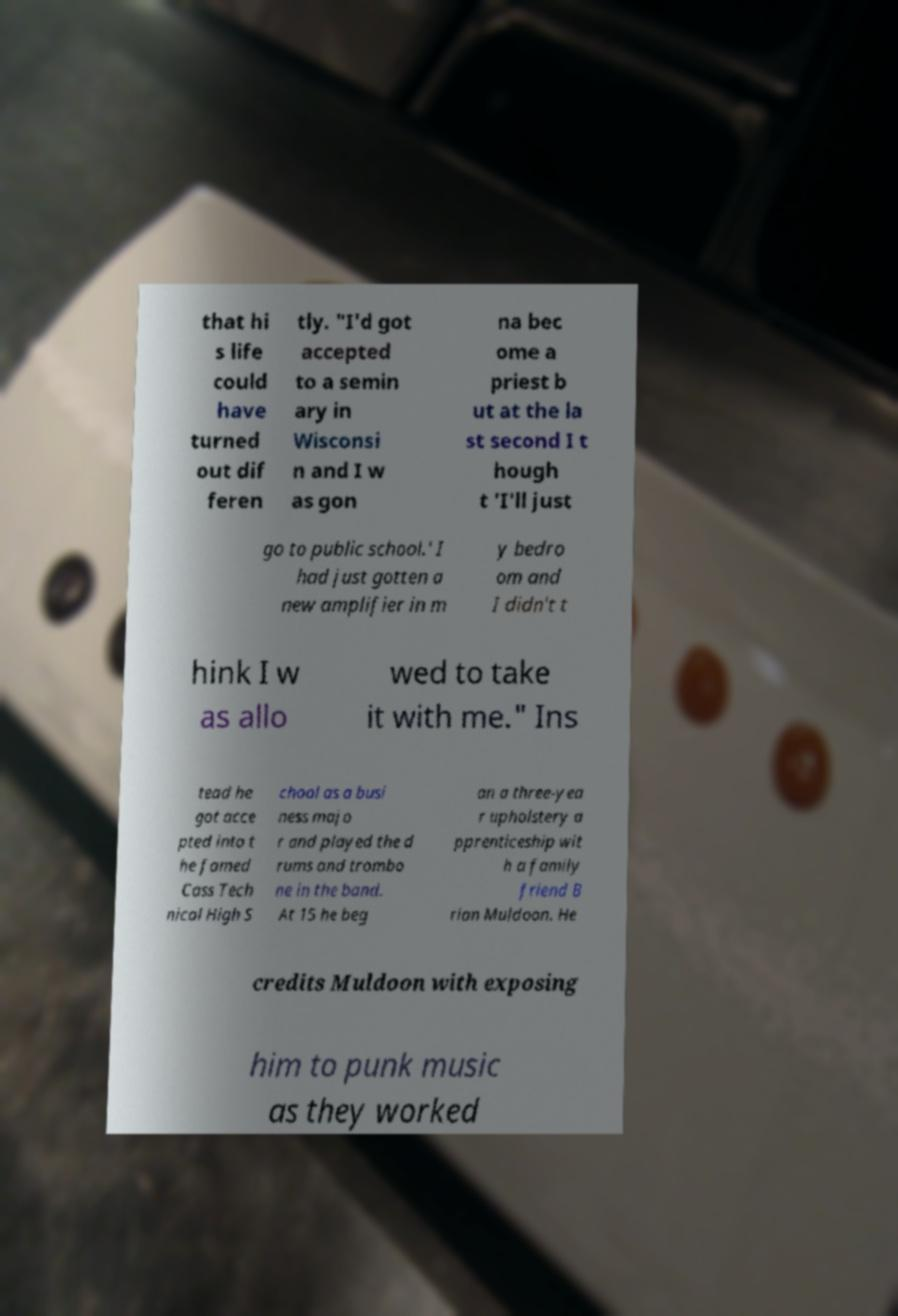Can you accurately transcribe the text from the provided image for me? that hi s life could have turned out dif feren tly. "I'd got accepted to a semin ary in Wisconsi n and I w as gon na bec ome a priest b ut at the la st second I t hough t 'I'll just go to public school.' I had just gotten a new amplifier in m y bedro om and I didn't t hink I w as allo wed to take it with me." Ins tead he got acce pted into t he famed Cass Tech nical High S chool as a busi ness majo r and played the d rums and trombo ne in the band. At 15 he beg an a three-yea r upholstery a pprenticeship wit h a family friend B rian Muldoon. He credits Muldoon with exposing him to punk music as they worked 